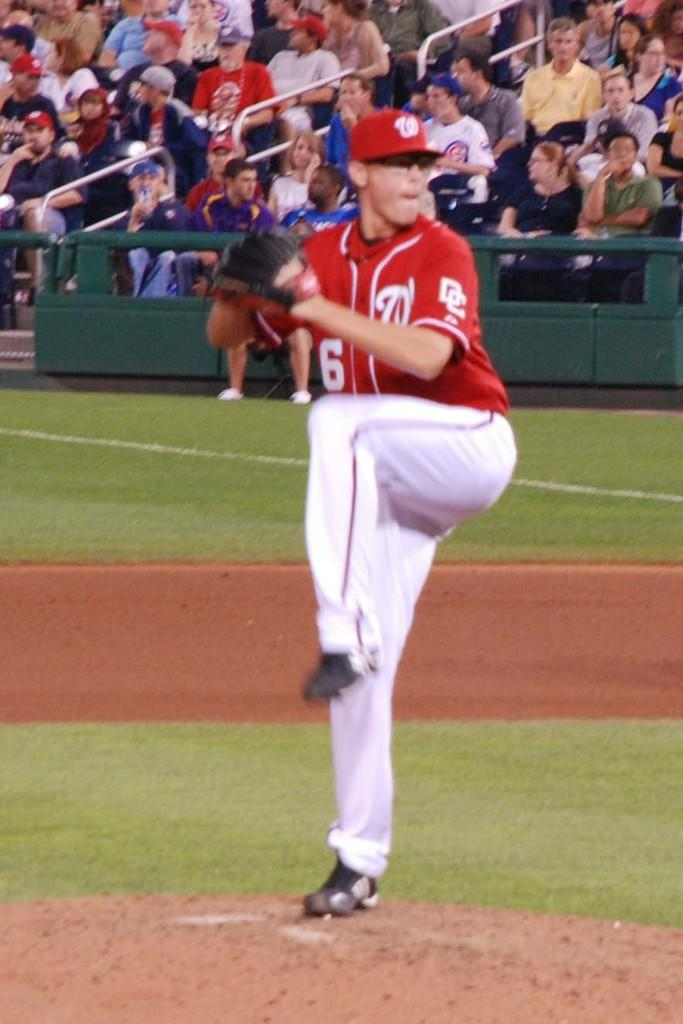<image>
Give a short and clear explanation of the subsequent image. A baseball player with the number 6 on his red jersey is winding up to pitch the ball. 